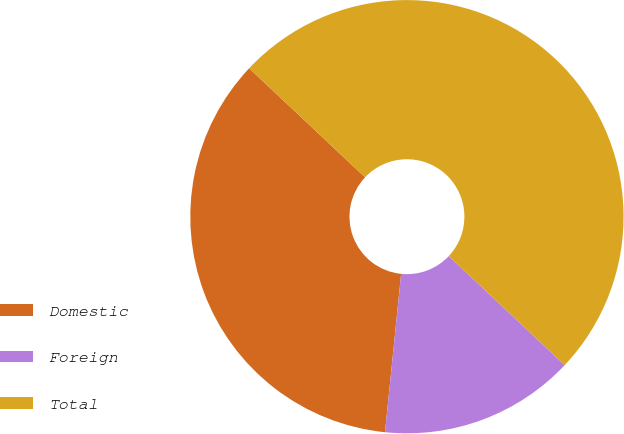Convert chart. <chart><loc_0><loc_0><loc_500><loc_500><pie_chart><fcel>Domestic<fcel>Foreign<fcel>Total<nl><fcel>35.4%<fcel>14.6%<fcel>50.0%<nl></chart> 